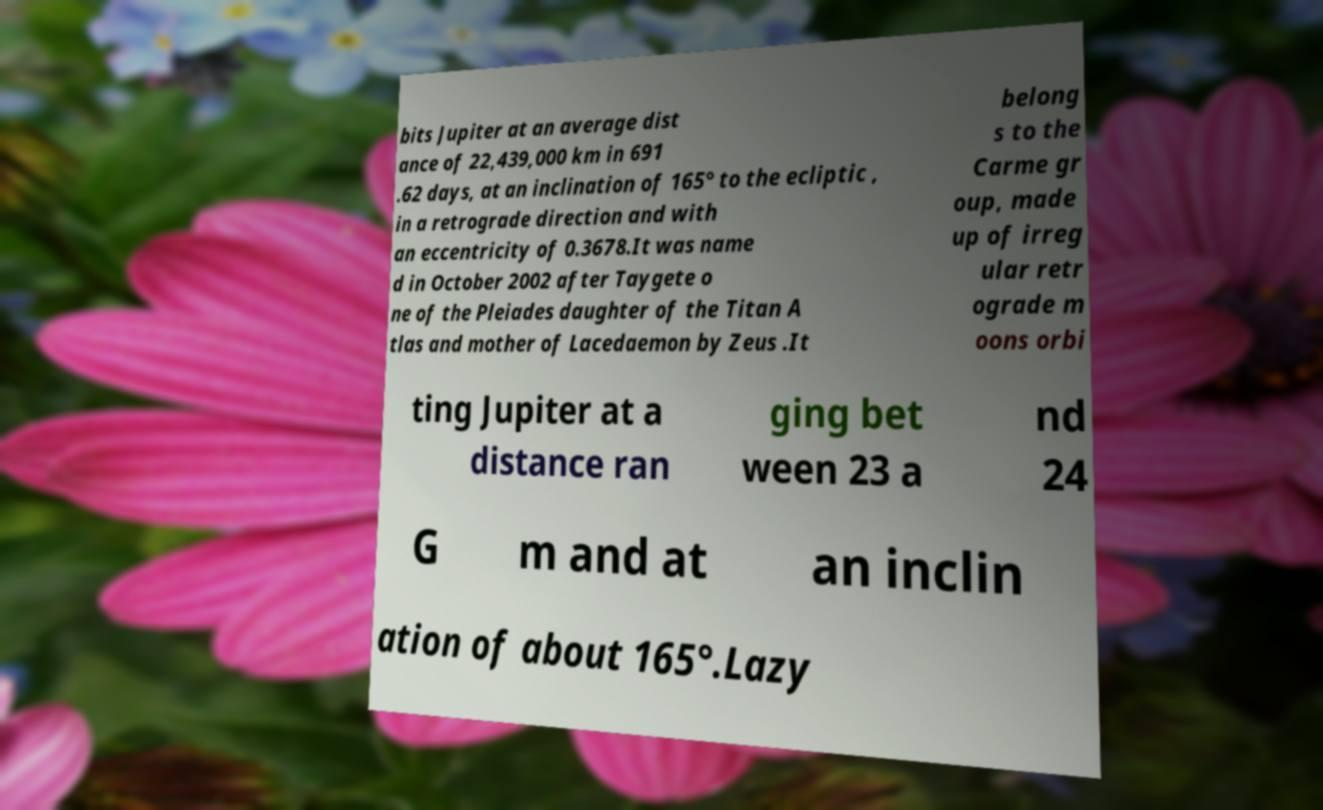Please read and relay the text visible in this image. What does it say? bits Jupiter at an average dist ance of 22,439,000 km in 691 .62 days, at an inclination of 165° to the ecliptic , in a retrograde direction and with an eccentricity of 0.3678.It was name d in October 2002 after Taygete o ne of the Pleiades daughter of the Titan A tlas and mother of Lacedaemon by Zeus .It belong s to the Carme gr oup, made up of irreg ular retr ograde m oons orbi ting Jupiter at a distance ran ging bet ween 23 a nd 24 G m and at an inclin ation of about 165°.Lazy 